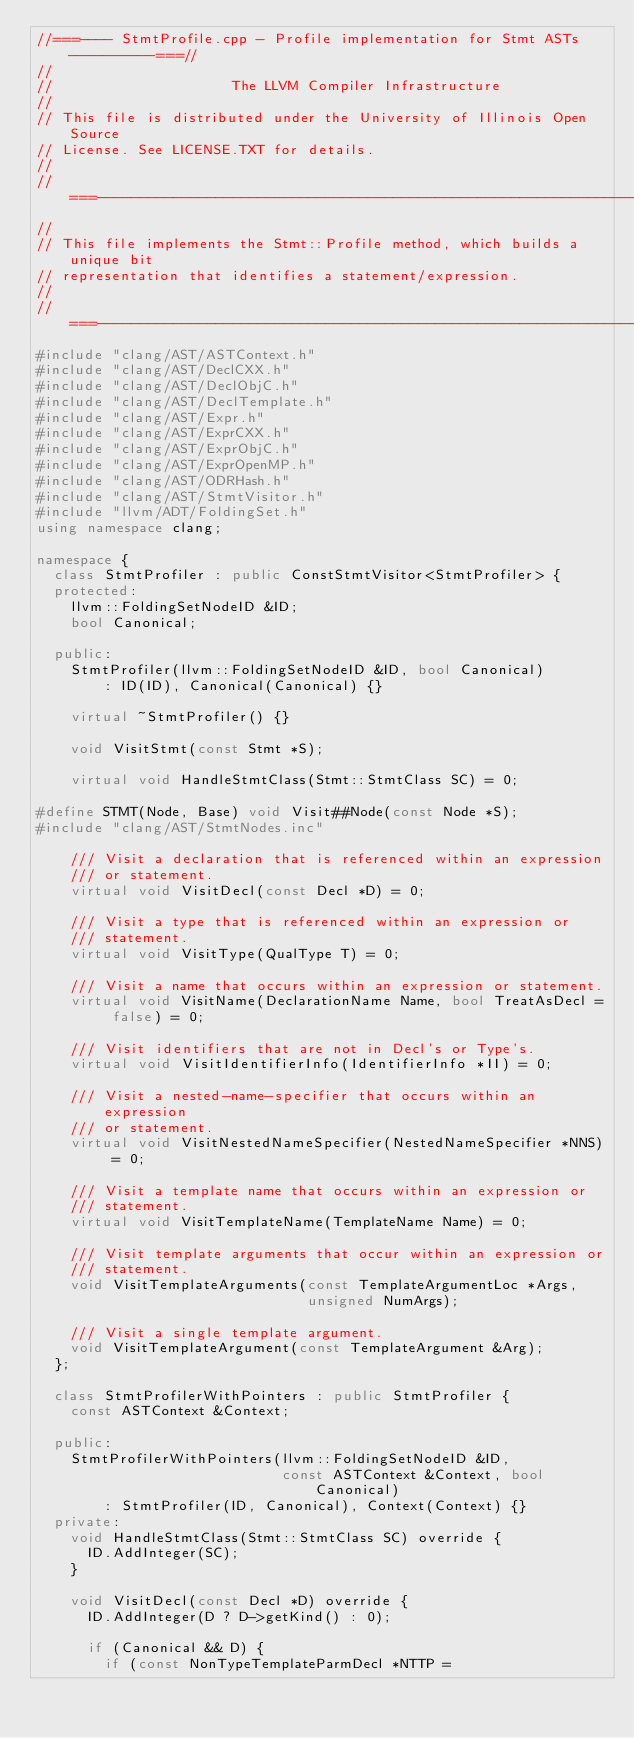Convert code to text. <code><loc_0><loc_0><loc_500><loc_500><_C++_>//===---- StmtProfile.cpp - Profile implementation for Stmt ASTs ----------===//
//
//                     The LLVM Compiler Infrastructure
//
// This file is distributed under the University of Illinois Open Source
// License. See LICENSE.TXT for details.
//
//===----------------------------------------------------------------------===//
//
// This file implements the Stmt::Profile method, which builds a unique bit
// representation that identifies a statement/expression.
//
//===----------------------------------------------------------------------===//
#include "clang/AST/ASTContext.h"
#include "clang/AST/DeclCXX.h"
#include "clang/AST/DeclObjC.h"
#include "clang/AST/DeclTemplate.h"
#include "clang/AST/Expr.h"
#include "clang/AST/ExprCXX.h"
#include "clang/AST/ExprObjC.h"
#include "clang/AST/ExprOpenMP.h"
#include "clang/AST/ODRHash.h"
#include "clang/AST/StmtVisitor.h"
#include "llvm/ADT/FoldingSet.h"
using namespace clang;

namespace {
  class StmtProfiler : public ConstStmtVisitor<StmtProfiler> {
  protected:
    llvm::FoldingSetNodeID &ID;
    bool Canonical;

  public:
    StmtProfiler(llvm::FoldingSetNodeID &ID, bool Canonical)
        : ID(ID), Canonical(Canonical) {}

    virtual ~StmtProfiler() {}

    void VisitStmt(const Stmt *S);

    virtual void HandleStmtClass(Stmt::StmtClass SC) = 0;

#define STMT(Node, Base) void Visit##Node(const Node *S);
#include "clang/AST/StmtNodes.inc"

    /// Visit a declaration that is referenced within an expression
    /// or statement.
    virtual void VisitDecl(const Decl *D) = 0;

    /// Visit a type that is referenced within an expression or
    /// statement.
    virtual void VisitType(QualType T) = 0;

    /// Visit a name that occurs within an expression or statement.
    virtual void VisitName(DeclarationName Name, bool TreatAsDecl = false) = 0;

    /// Visit identifiers that are not in Decl's or Type's.
    virtual void VisitIdentifierInfo(IdentifierInfo *II) = 0;

    /// Visit a nested-name-specifier that occurs within an expression
    /// or statement.
    virtual void VisitNestedNameSpecifier(NestedNameSpecifier *NNS) = 0;

    /// Visit a template name that occurs within an expression or
    /// statement.
    virtual void VisitTemplateName(TemplateName Name) = 0;

    /// Visit template arguments that occur within an expression or
    /// statement.
    void VisitTemplateArguments(const TemplateArgumentLoc *Args,
                                unsigned NumArgs);

    /// Visit a single template argument.
    void VisitTemplateArgument(const TemplateArgument &Arg);
  };

  class StmtProfilerWithPointers : public StmtProfiler {
    const ASTContext &Context;

  public:
    StmtProfilerWithPointers(llvm::FoldingSetNodeID &ID,
                             const ASTContext &Context, bool Canonical)
        : StmtProfiler(ID, Canonical), Context(Context) {}
  private:
    void HandleStmtClass(Stmt::StmtClass SC) override {
      ID.AddInteger(SC);
    }

    void VisitDecl(const Decl *D) override {
      ID.AddInteger(D ? D->getKind() : 0);

      if (Canonical && D) {
        if (const NonTypeTemplateParmDecl *NTTP =</code> 